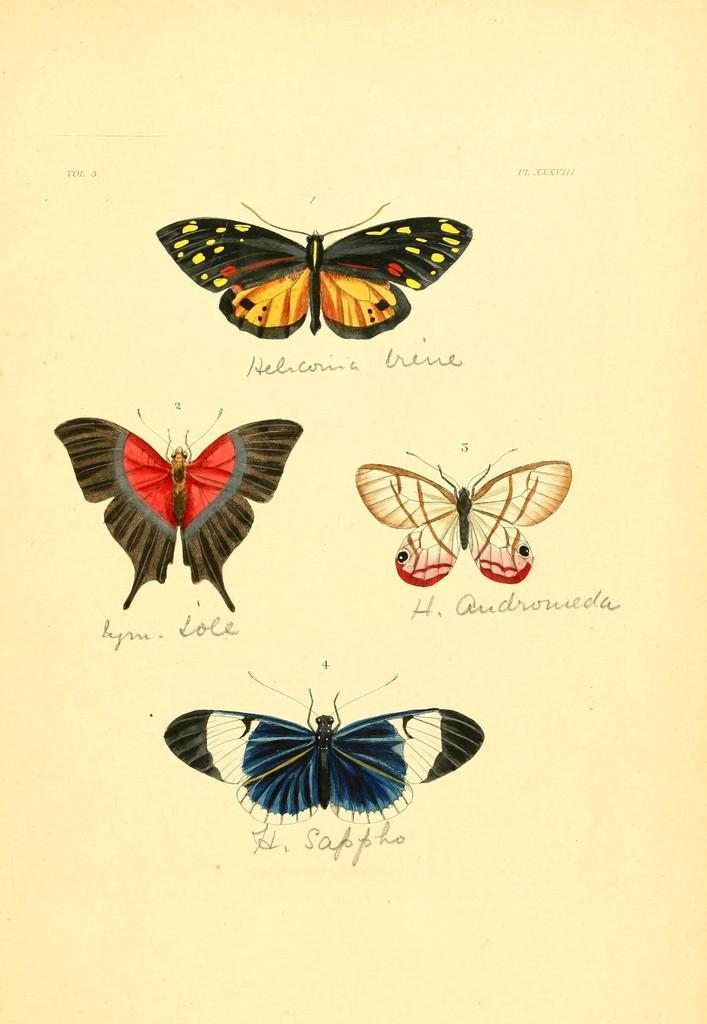Can you describe this image briefly? In this image we can see a picture of some butterflies and some text on it. 